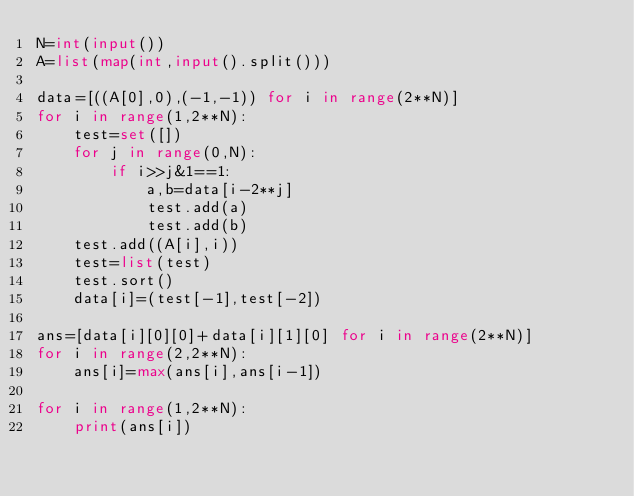<code> <loc_0><loc_0><loc_500><loc_500><_Python_>N=int(input())
A=list(map(int,input().split()))

data=[((A[0],0),(-1,-1)) for i in range(2**N)]
for i in range(1,2**N):
    test=set([])
    for j in range(0,N):
        if i>>j&1==1:
            a,b=data[i-2**j]
            test.add(a)
            test.add(b)
    test.add((A[i],i))
    test=list(test)
    test.sort()
    data[i]=(test[-1],test[-2])

ans=[data[i][0][0]+data[i][1][0] for i in range(2**N)]
for i in range(2,2**N):
    ans[i]=max(ans[i],ans[i-1])

for i in range(1,2**N):
    print(ans[i])
</code> 